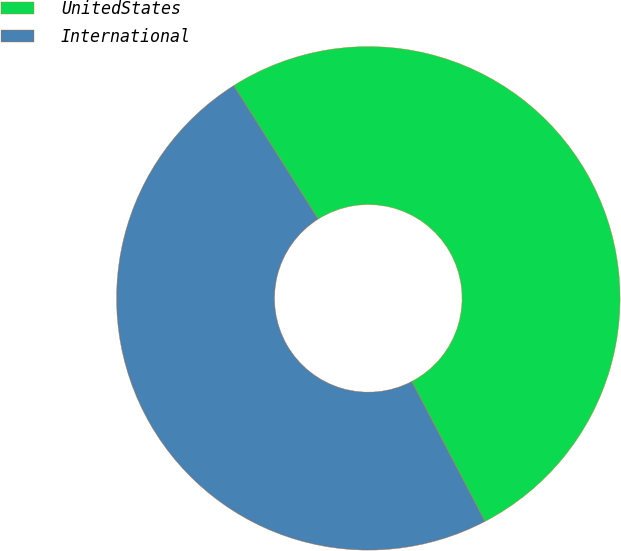<chart> <loc_0><loc_0><loc_500><loc_500><pie_chart><fcel>UnitedStates<fcel>International<nl><fcel>51.31%<fcel>48.69%<nl></chart> 